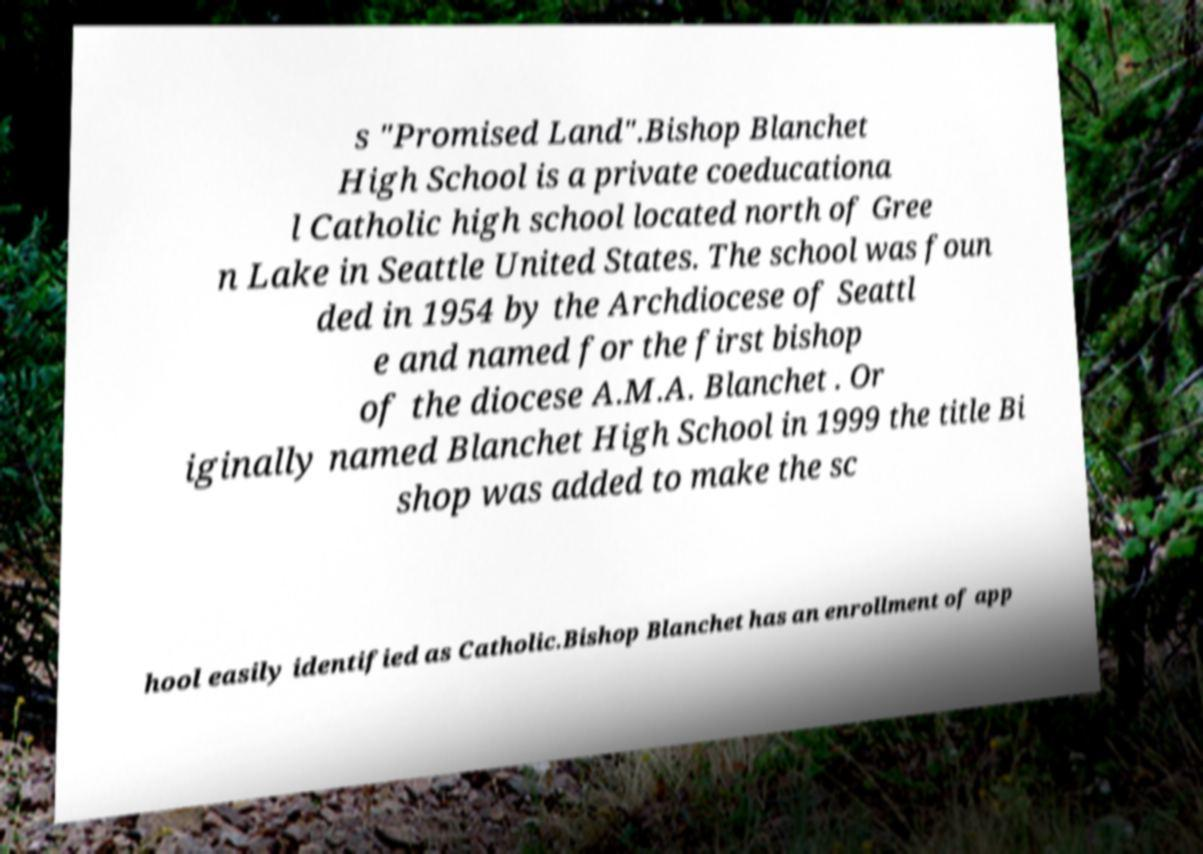Can you accurately transcribe the text from the provided image for me? s "Promised Land".Bishop Blanchet High School is a private coeducationa l Catholic high school located north of Gree n Lake in Seattle United States. The school was foun ded in 1954 by the Archdiocese of Seattl e and named for the first bishop of the diocese A.M.A. Blanchet . Or iginally named Blanchet High School in 1999 the title Bi shop was added to make the sc hool easily identified as Catholic.Bishop Blanchet has an enrollment of app 